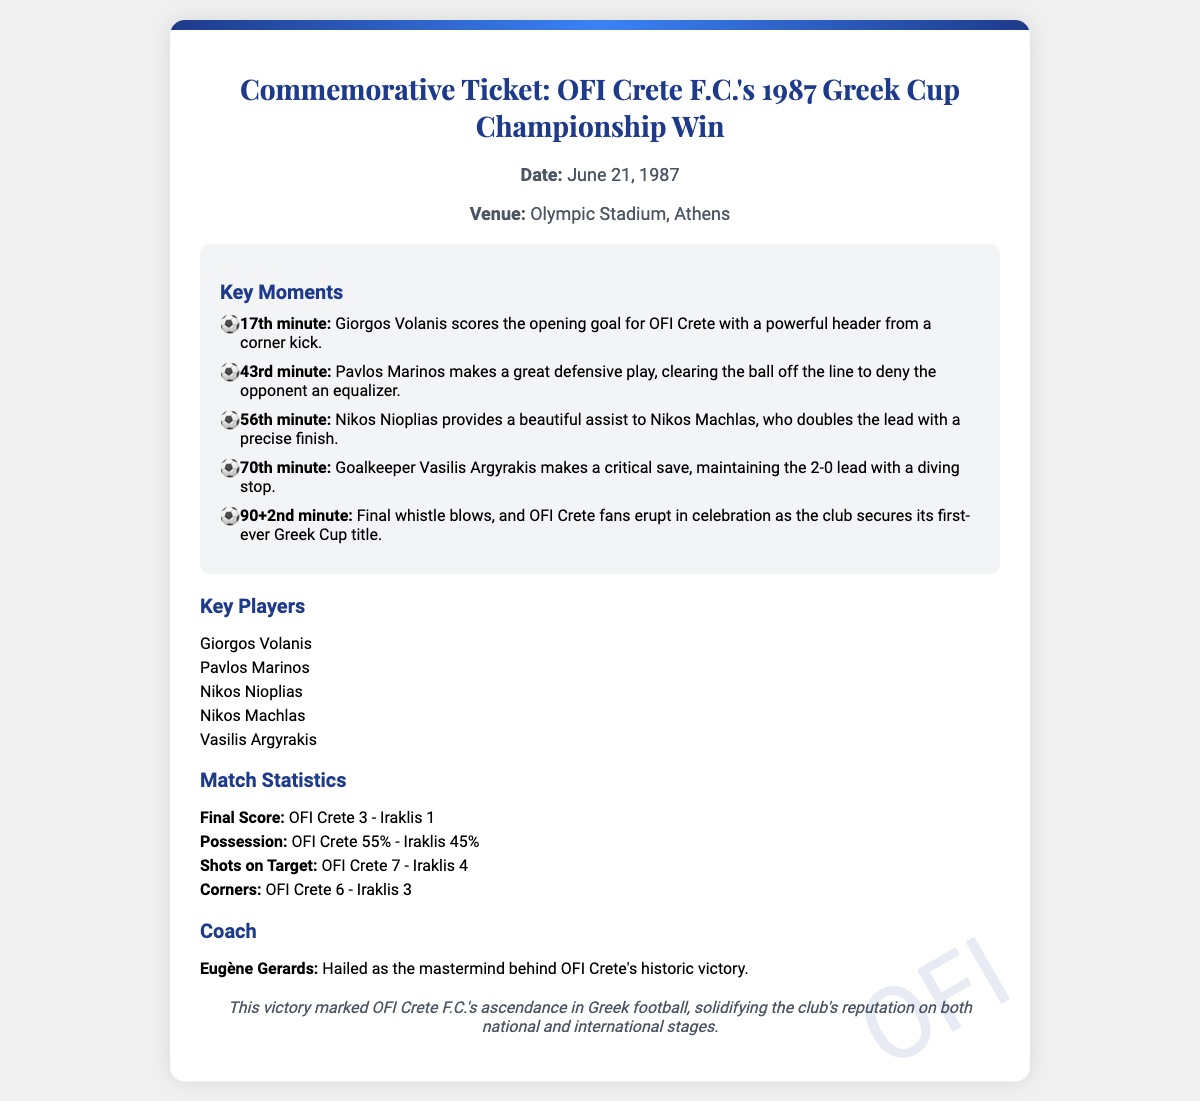What date was the championship match held? The date is mentioned in the document as June 21, 1987.
Answer: June 21, 1987 Where did OFI Crete win the Greek Cup Championship? The venue for the match is listed as Olympic Stadium, Athens.
Answer: Olympic Stadium, Athens Who scored the opening goal for OFI Crete? The document states that Giorgos Volanis scored the opening goal for OFI Crete.
Answer: Giorgos Volanis What was the final score of the match? The final score is provided in the statistics section as OFI Crete 3 - Iraklis 1.
Answer: OFI Crete 3 - Iraklis 1 Who was the coach of OFI Crete during the championship? The document names Eugène Gerards as the coach of OFI Crete.
Answer: Eugène Gerards In which minute did the final whistle blow? The document specifies that the final whistle blew in the 90+2nd minute.
Answer: 90+2nd minute What role did Pavlos Marinos play during the match? The document highlights that Pavlos Marinos made a great defensive play in the 43rd minute.
Answer: Defensive play How many shots on target did OFI Crete have? The match statistics indicate that OFI Crete had 7 shots on target.
Answer: 7 What was the significance of this victory for OFI Crete F.C.? The special note emphasizes that this victory marked OFI Crete F.C.'s ascendance in Greek football.
Answer: Ascendance in Greek football 